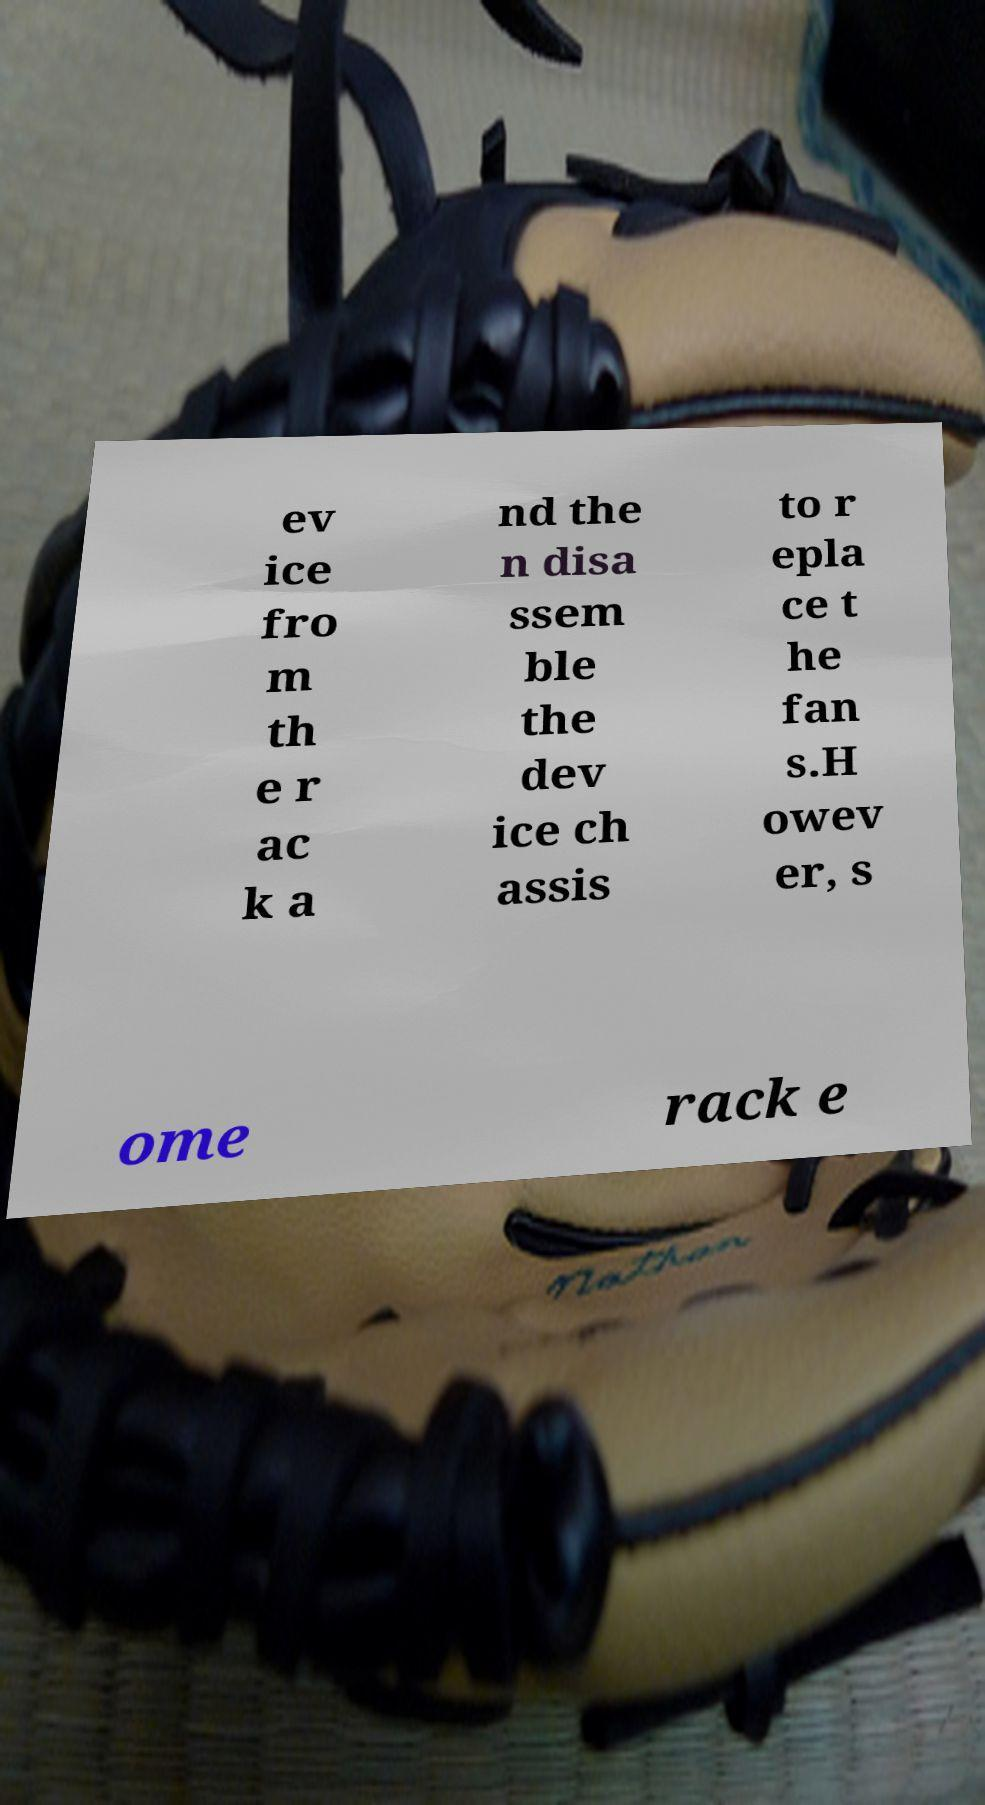Could you extract and type out the text from this image? ev ice fro m th e r ac k a nd the n disa ssem ble the dev ice ch assis to r epla ce t he fan s.H owev er, s ome rack e 